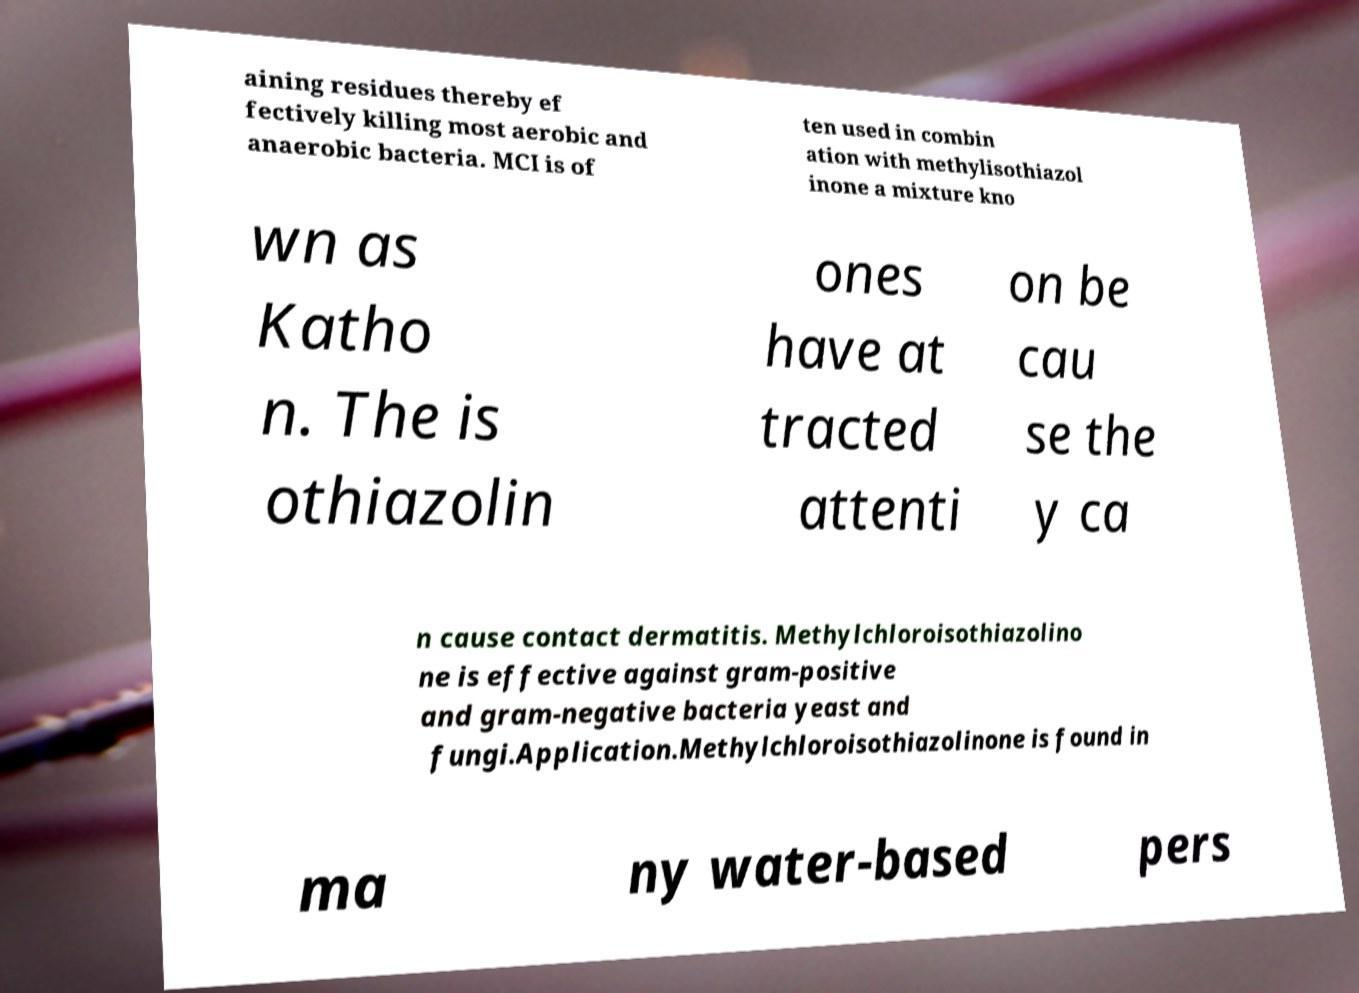Please read and relay the text visible in this image. What does it say? aining residues thereby ef fectively killing most aerobic and anaerobic bacteria. MCI is of ten used in combin ation with methylisothiazol inone a mixture kno wn as Katho n. The is othiazolin ones have at tracted attenti on be cau se the y ca n cause contact dermatitis. Methylchloroisothiazolino ne is effective against gram-positive and gram-negative bacteria yeast and fungi.Application.Methylchloroisothiazolinone is found in ma ny water-based pers 